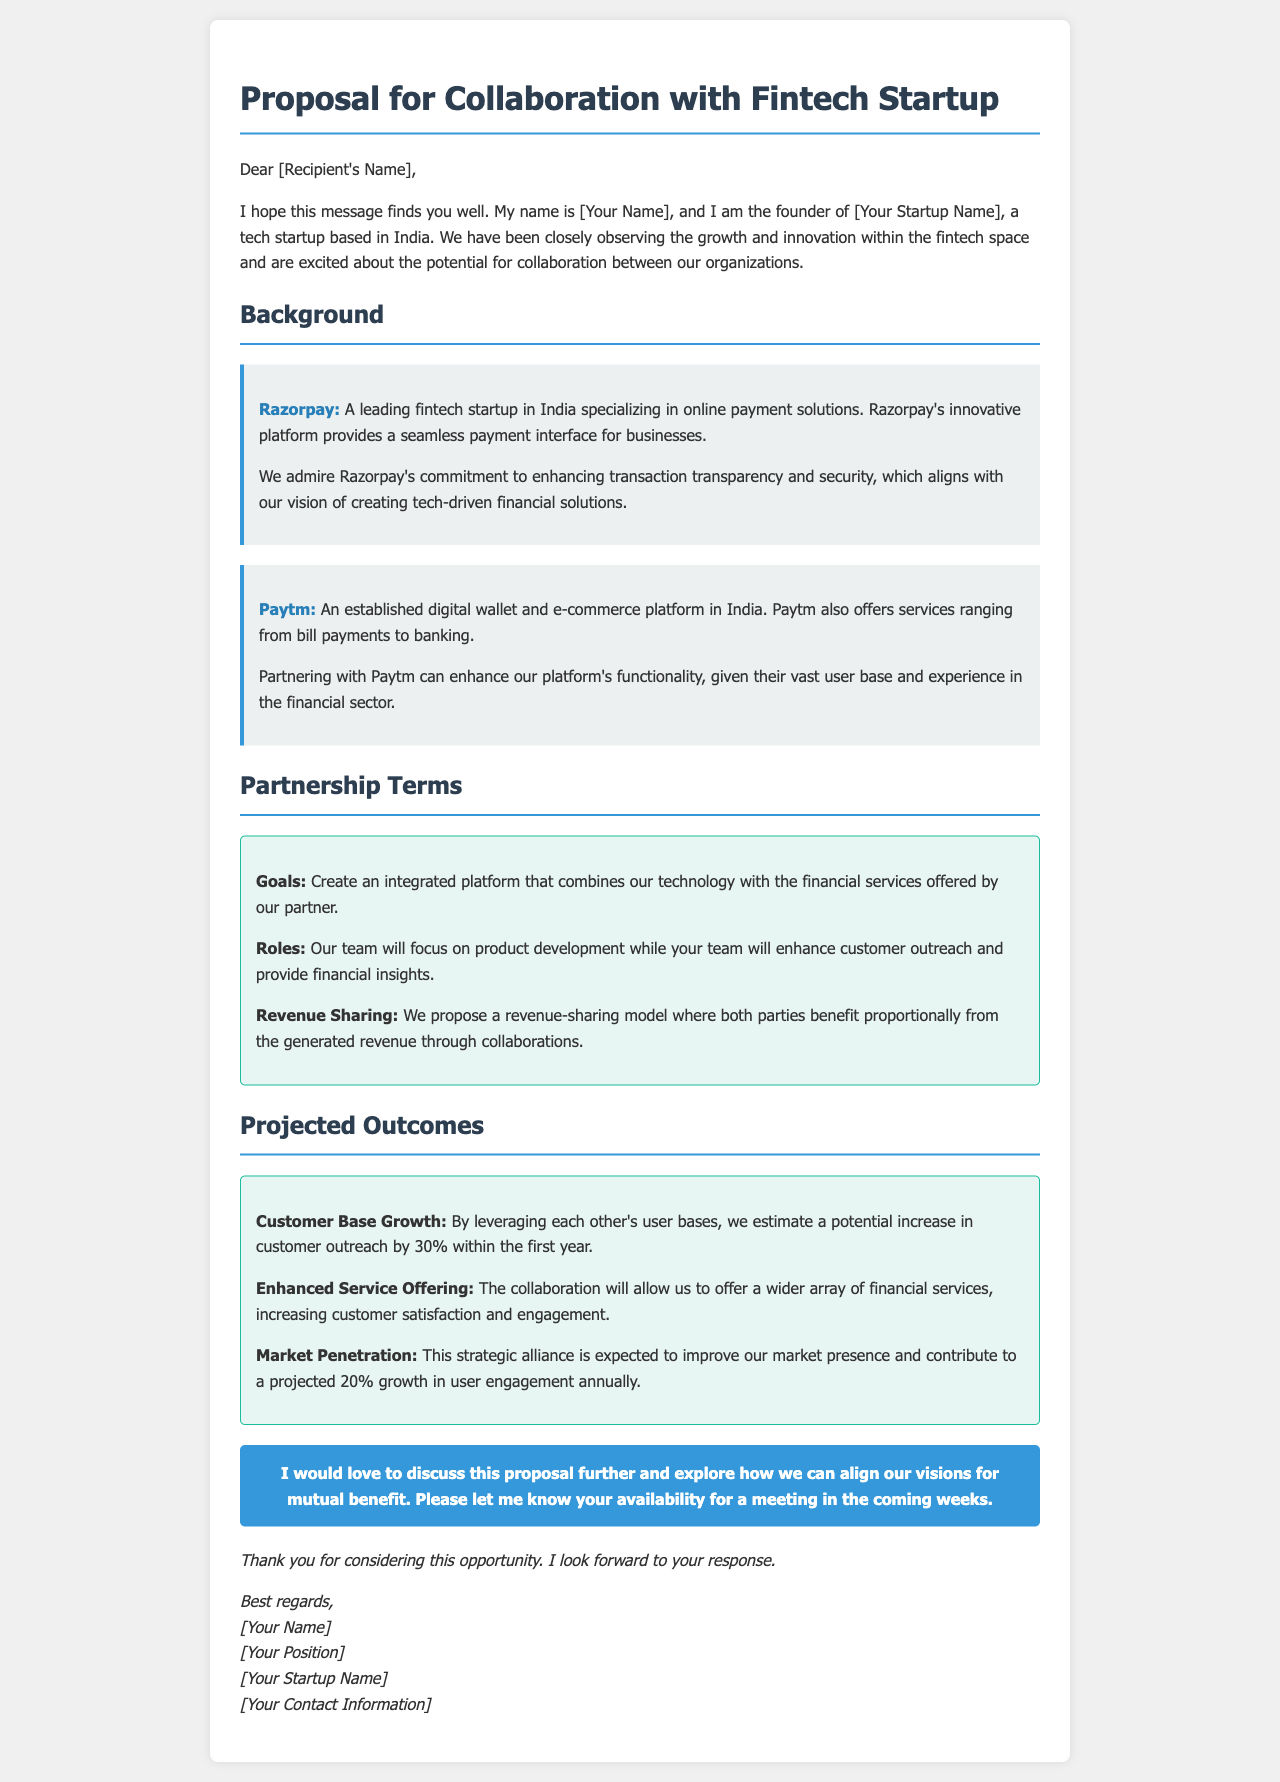What is the name of the sender's startup? The name of the sender's startup is mentioned as [Your Startup Name].
Answer: [Your Startup Name] What are the names of the two fintech startups mentioned? The document mentions Razorpay and Paytm as the two fintech startups.
Answer: Razorpay, Paytm What is the projected percentage increase in customer outreach? The document states that there is a potential increase in customer outreach by 30% within the first year.
Answer: 30% What are the two main areas where each team will focus? The document indicates that one team will focus on product development and the other on customer outreach and financial insights.
Answer: Product development, customer outreach What is the proposed revenue-sharing model? The proposal outlines a revenue-sharing model where both parties benefit proportionally from the generated revenue.
Answer: Proportional revenue-sharing What is the expected annual growth in user engagement? The expected growth in user engagement annually is projected to be 20%.
Answer: 20% What is the purpose of the call-to-action section? The call-to-action section invites the recipient to discuss the proposal further and explore mutual benefit opportunities.
Answer: Discuss proposal further What specific collaboration goal is mentioned? The main collaboration goal is to create an integrated platform combining technology with financial services.
Answer: Integrated platform 